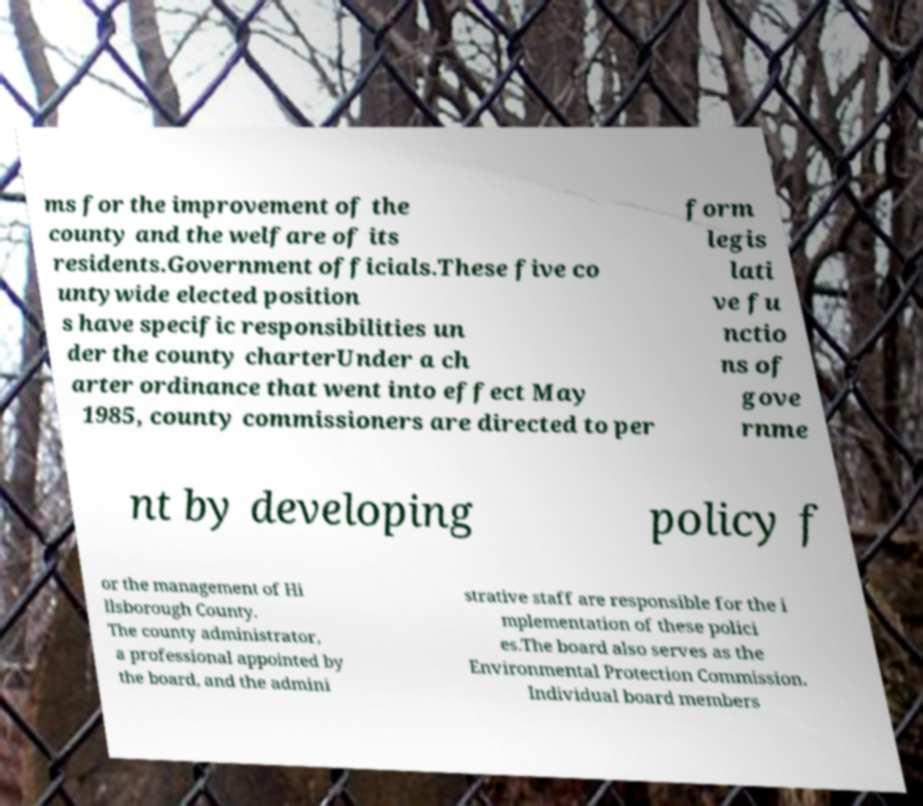What messages or text are displayed in this image? I need them in a readable, typed format. ms for the improvement of the county and the welfare of its residents.Government officials.These five co untywide elected position s have specific responsibilities un der the county charterUnder a ch arter ordinance that went into effect May 1985, county commissioners are directed to per form legis lati ve fu nctio ns of gove rnme nt by developing policy f or the management of Hi llsborough County. The county administrator, a professional appointed by the board, and the admini strative staff are responsible for the i mplementation of these polici es.The board also serves as the Environmental Protection Commission. Individual board members 